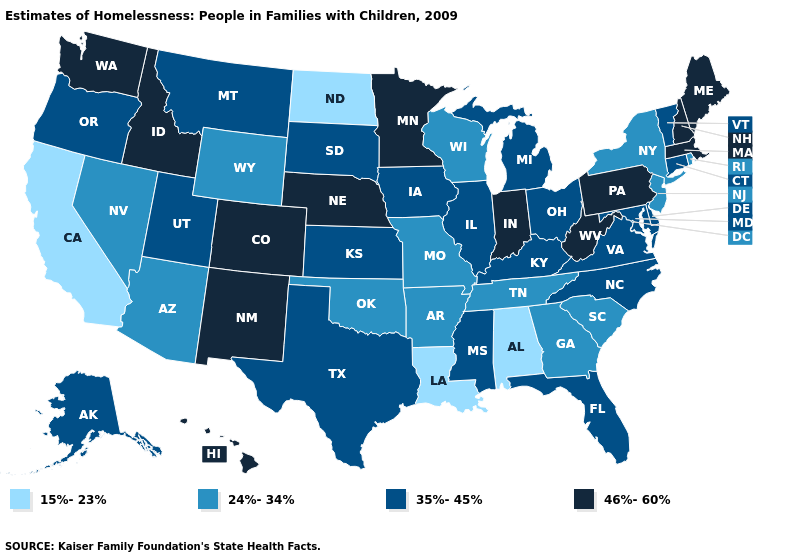Among the states that border West Virginia , which have the lowest value?
Concise answer only. Kentucky, Maryland, Ohio, Virginia. Does North Carolina have a higher value than Colorado?
Short answer required. No. What is the value of New Jersey?
Give a very brief answer. 24%-34%. Name the states that have a value in the range 24%-34%?
Be succinct. Arizona, Arkansas, Georgia, Missouri, Nevada, New Jersey, New York, Oklahoma, Rhode Island, South Carolina, Tennessee, Wisconsin, Wyoming. What is the lowest value in the Northeast?
Short answer required. 24%-34%. Among the states that border Pennsylvania , does Maryland have the highest value?
Give a very brief answer. No. Which states have the lowest value in the USA?
Keep it brief. Alabama, California, Louisiana, North Dakota. What is the lowest value in the USA?
Short answer required. 15%-23%. Does the map have missing data?
Write a very short answer. No. Which states have the lowest value in the Northeast?
Be succinct. New Jersey, New York, Rhode Island. What is the value of Texas?
Keep it brief. 35%-45%. Does Alabama have a higher value than Utah?
Quick response, please. No. What is the value of Colorado?
Give a very brief answer. 46%-60%. Does Delaware have a lower value than Colorado?
Be succinct. Yes. Name the states that have a value in the range 46%-60%?
Quick response, please. Colorado, Hawaii, Idaho, Indiana, Maine, Massachusetts, Minnesota, Nebraska, New Hampshire, New Mexico, Pennsylvania, Washington, West Virginia. 